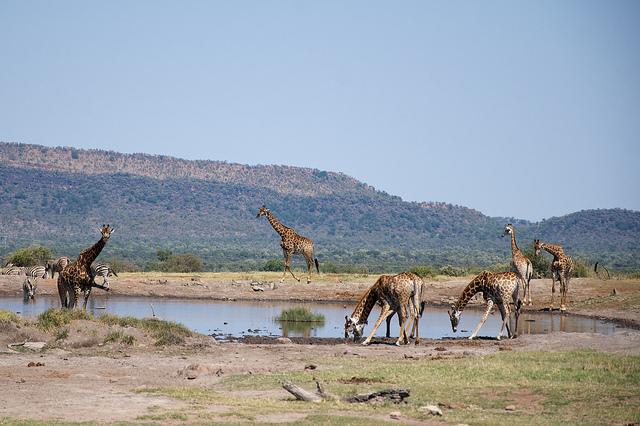Is there a lot of grass in this picture?
Keep it brief. No. Overcast or sunny?
Short answer required. Sunny. About how many animals are out there in the wild?
Quick response, please. 10. What is behind the animals?
Keep it brief. Mountains. Are there trees?
Concise answer only. No. 